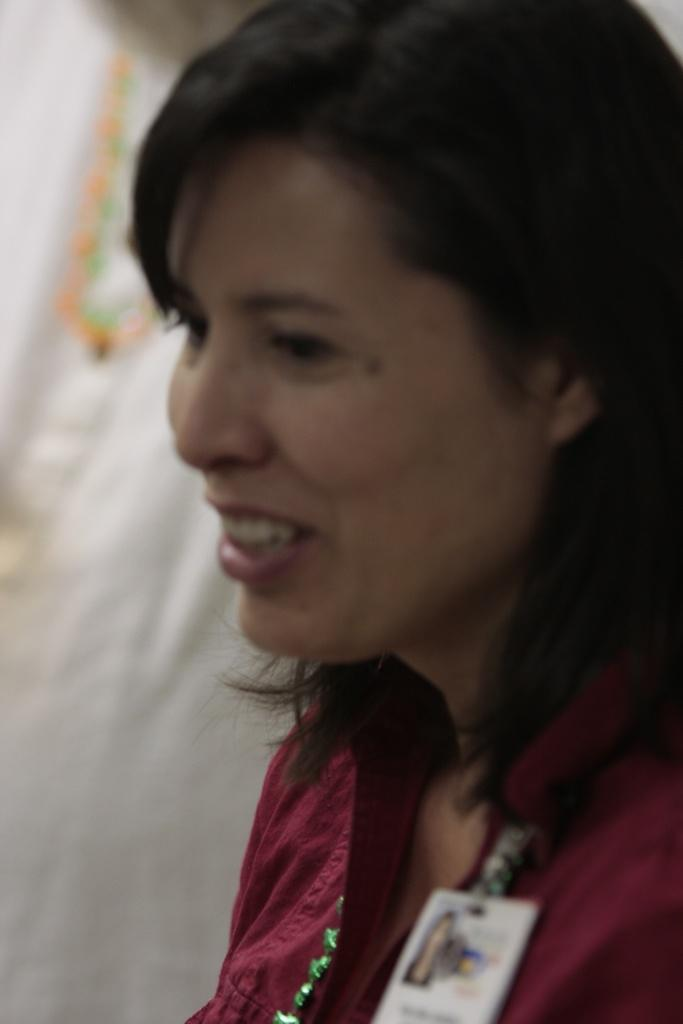What is the main subject of the image? The main subject of the image is a woman. What is the woman doing in the image? The woman is smiling in the image. What color is the shirt the woman is wearing? The woman is wearing a dark red color shirt. How many planes can be seen flying in the image? There are no planes visible in the image. What type of humor is the woman telling in the image? The image does not depict the woman telling a joke or engaging in any humor. 